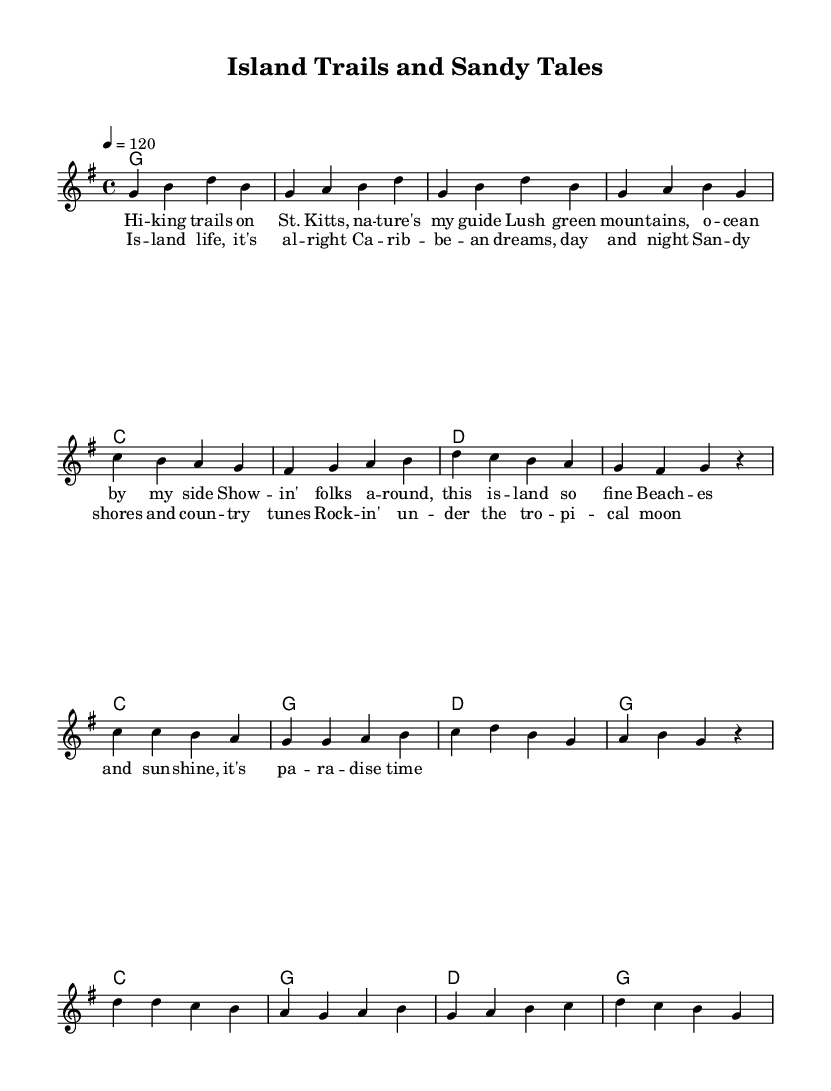What is the key signature of this music? The key signature is indicated at the beginning of the piece, which shows one sharp. This corresponds to the key of G major.
Answer: G major What is the time signature of this music? The time signature appears at the beginning of the score, indicating a repeating pattern of four beats per measure, which is described as 4/4.
Answer: 4/4 What is the tempo marking for this song? The tempo is indicated at the beginning of the score with a metronome marking, where the beats per minute are set to 120.
Answer: 120 How many measures are there in the verse section? By counting the measures designated for the verse in the melody section, which are clearly separated, there are a total of eight measures.
Answer: Eight What chord follows the first C chord in the chorus? In the chord progression provided, the first C chord in the chorus is followed by a G chord, as indicated by the chord symbols directly after the C.
Answer: G What is the theme of the chorus lyrics? Analyzing the lyrics of the chorus reveals a focus on the enjoyment of Caribbean island life and a celebration of nature and music, encapsulated in phrases like "Caribbean dreams" and "tropical moon."
Answer: Island life 